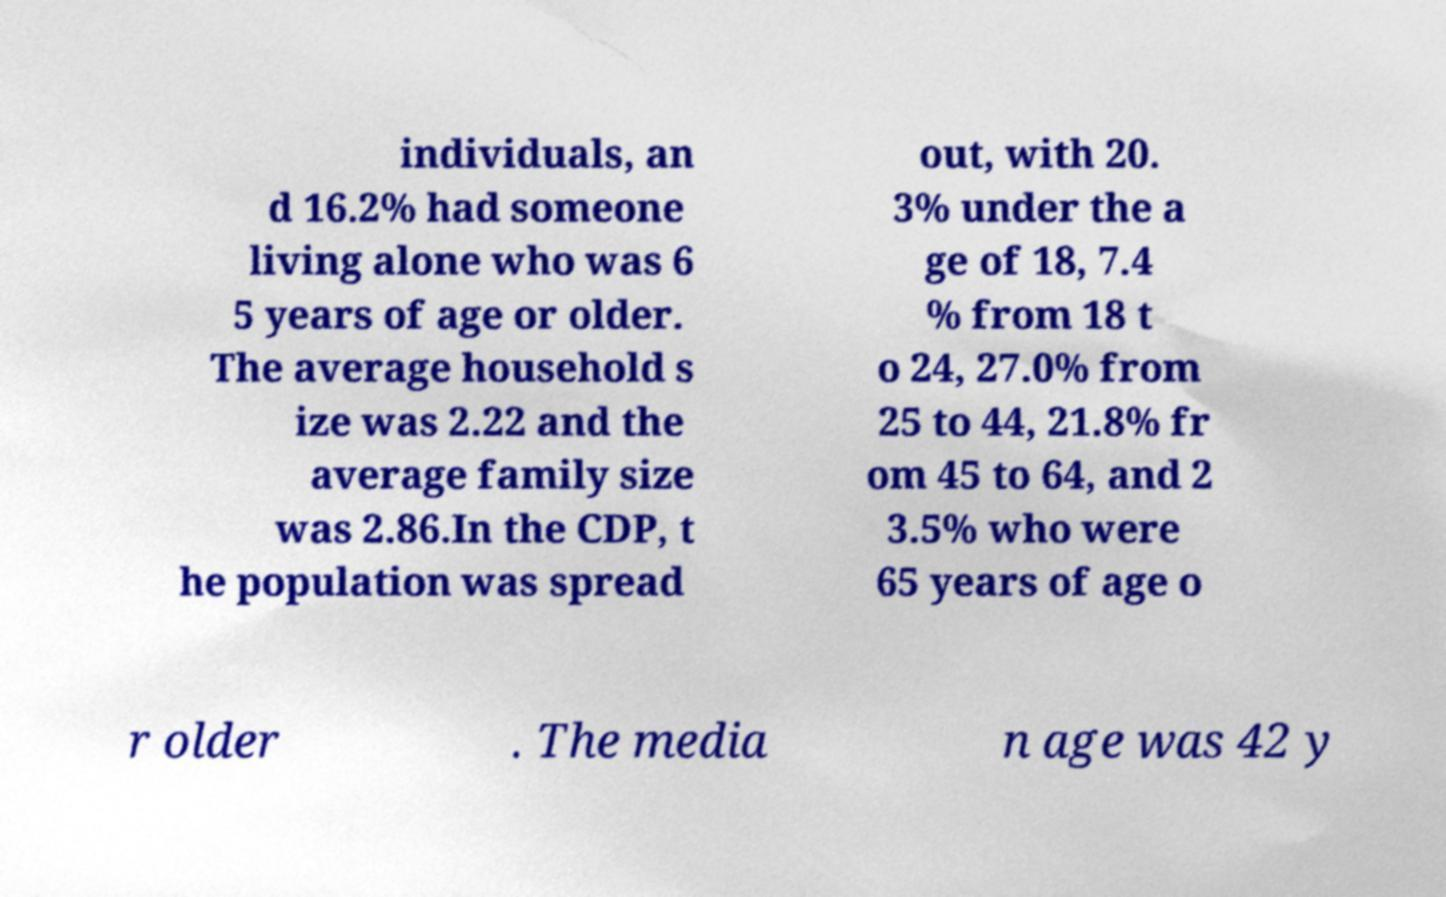There's text embedded in this image that I need extracted. Can you transcribe it verbatim? individuals, an d 16.2% had someone living alone who was 6 5 years of age or older. The average household s ize was 2.22 and the average family size was 2.86.In the CDP, t he population was spread out, with 20. 3% under the a ge of 18, 7.4 % from 18 t o 24, 27.0% from 25 to 44, 21.8% fr om 45 to 64, and 2 3.5% who were 65 years of age o r older . The media n age was 42 y 